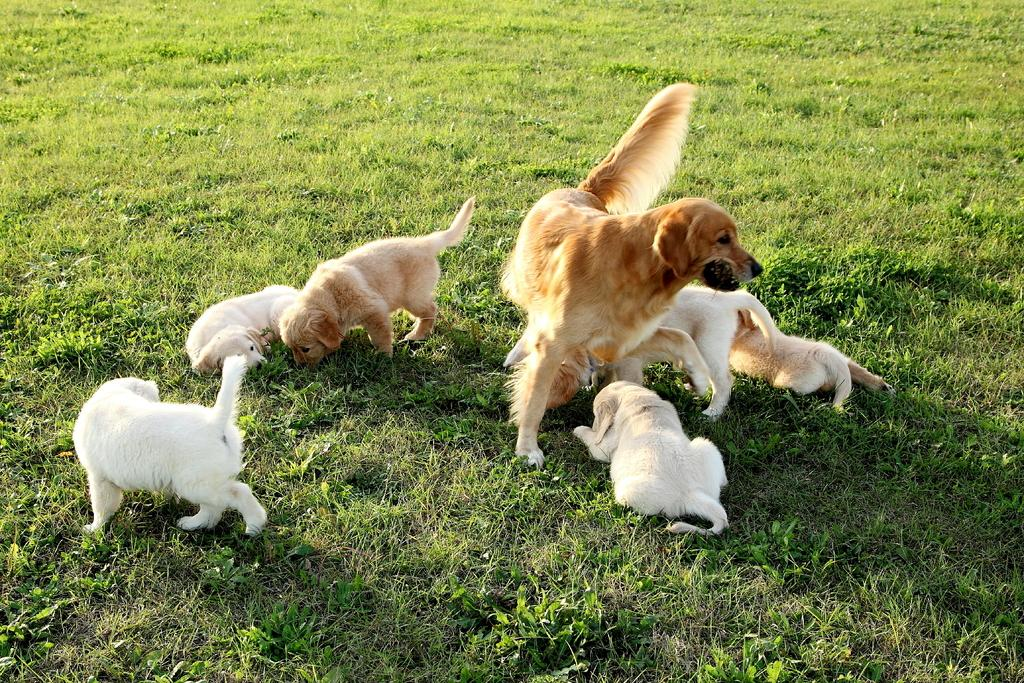What type of animals are present in the image? There are many dogs in the image. Can you describe the color of the dogs? The dogs are white and light brown in color. What type of environment can be seen in the image? There is grass visible in the image. What type of frame is around the art in the image? There is no art or frame present in the image; it features many dogs in a grassy environment. 